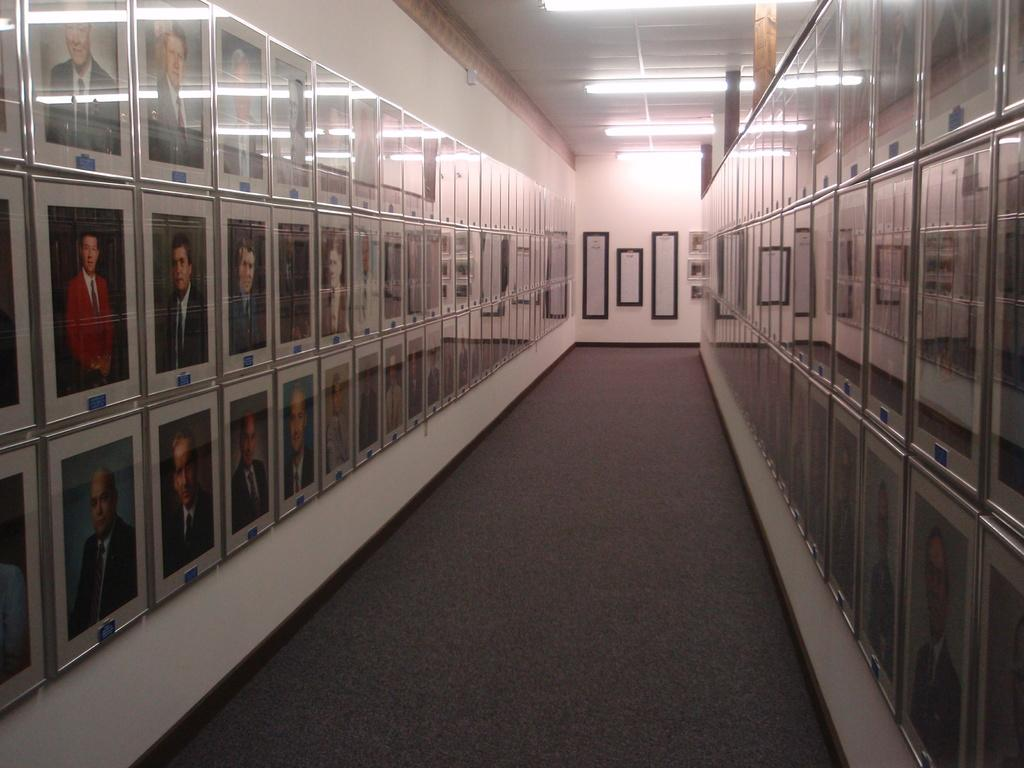What is present on the wall in the image? There are photo frames on the wall in the image. What type of illumination is visible in the image? There are lights in the image. What part of the building can be seen towards the top of the image? The roof is visible towards the top of the image. What part of the building can be seen towards the bottom of the image? The ground is visible towards the bottom of the image. What type of rock is being used to fix the wrench in the image? There is no rock or wrench present in the image. How many cubs can be seen playing with the lights in the image? There are no cubs present in the image. 